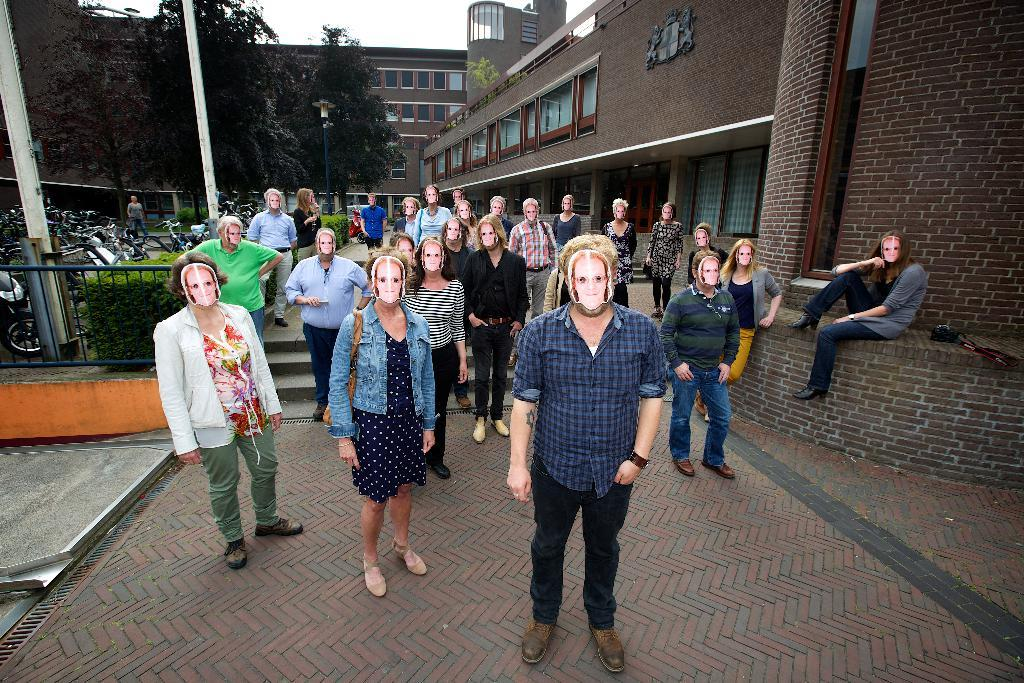What are the people in the image doing? The people in the image are standing and wearing masks. Is there anyone sitting in the image? Yes, there is a person sitting in the image. What can be seen in the background of the image? In the background of the image, there are vehicles, plants, trees, buildings, and the sky. What type of bulb is being discussed in the meeting in the image? There is no meeting or discussion of a bulb present in the image. How many houses are visible in the image? There are no houses visible in the image; only buildings are present in the background. 